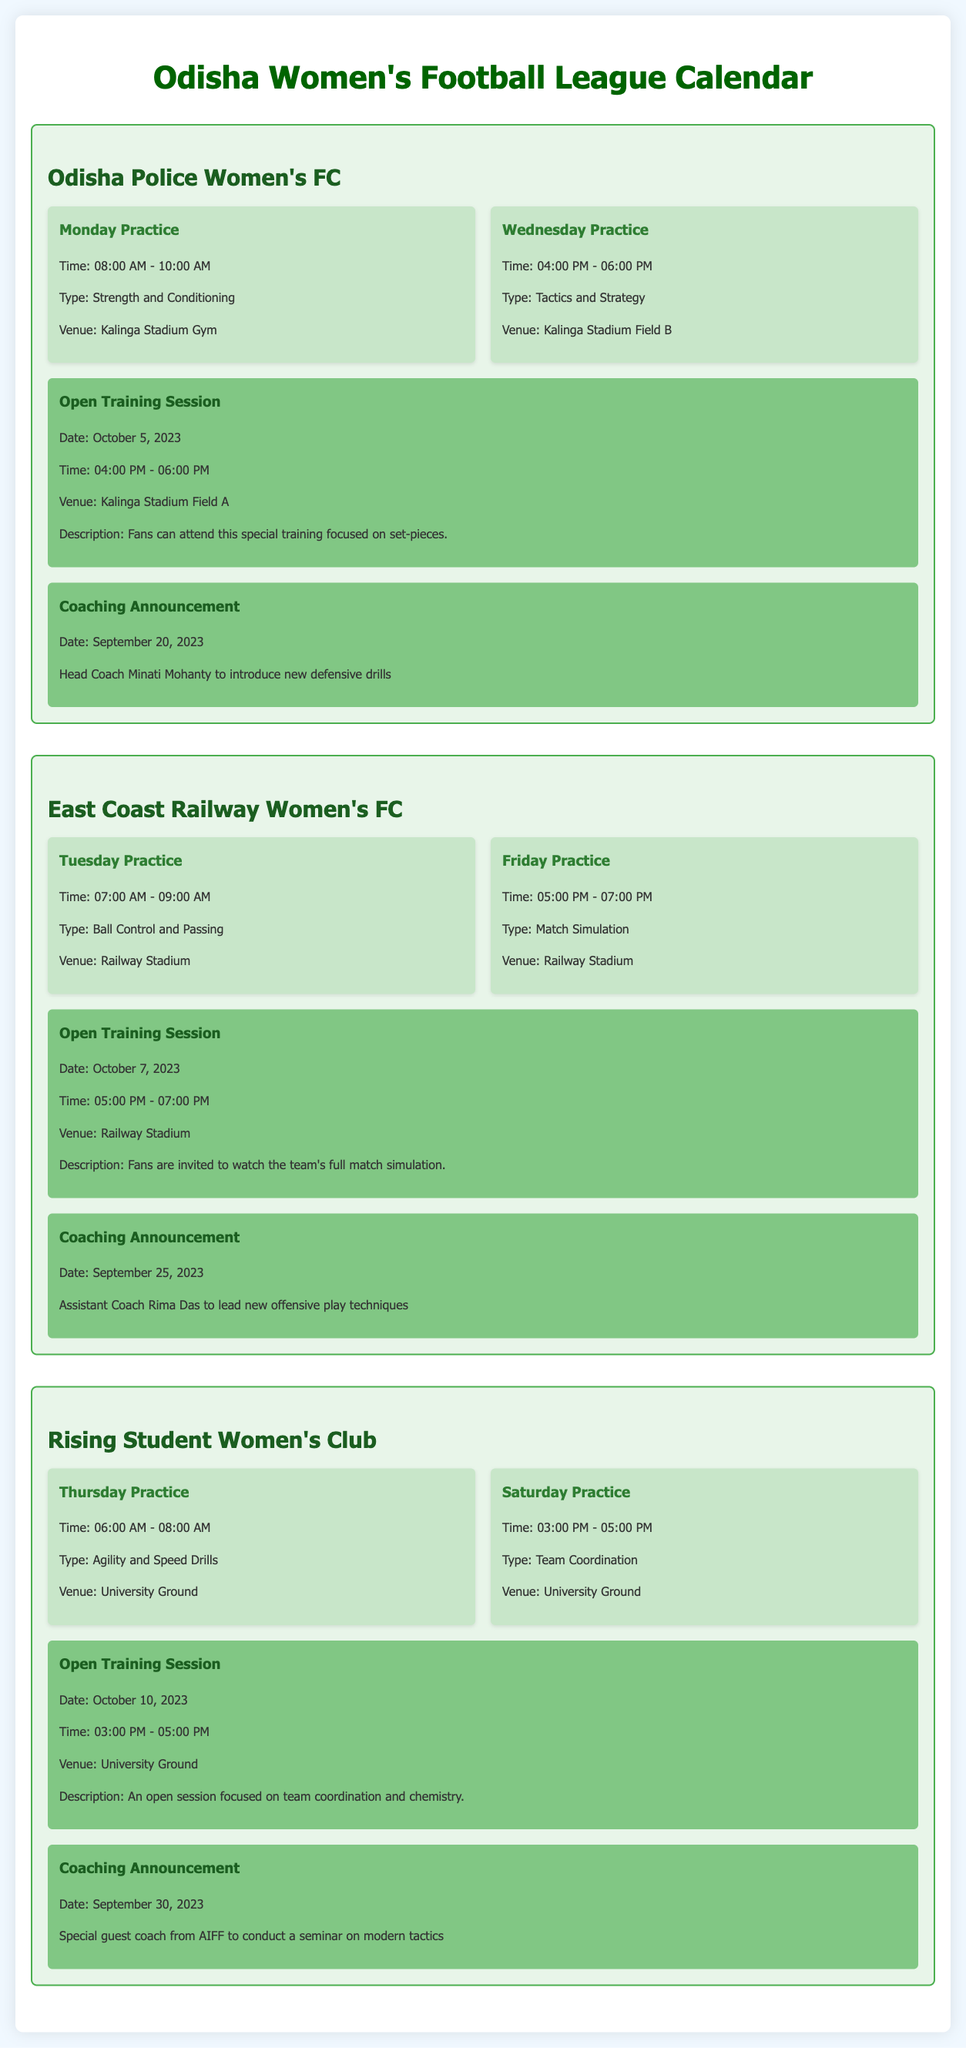what is the venue for the open training session on October 5, 2023? The venue for the open training session on October 5, 2023, is Kalinga Stadium Field A.
Answer: Kalinga Stadium Field A who is the head coach of Odisha Police Women's FC? The head coach of Odisha Police Women's FC is Minati Mohanty.
Answer: Minati Mohanty on which day does East Coast Railway Women's FC have practice focused on Ball Control and Passing? East Coast Railway Women's FC has practice focused on Ball Control and Passing on Tuesday.
Answer: Tuesday what type of practice is scheduled for Rising Student Women's Club on Thursday? The type of practice scheduled for Rising Student Women's Club on Thursday is Agility and Speed Drills.
Answer: Agility and Speed Drills how long is the open training session on October 10, 2023? The open training session on October 10, 2023, is from 03:00 PM to 05:00 PM, which is 2 hours long.
Answer: 2 hours what coaching announcement was made on September 30, 2023? The coaching announcement made on September 30, 2023, is that a special guest coach from AIFF will conduct a seminar on modern tactics.
Answer: special guest coach from AIFF to conduct a seminar on modern tactics what is the time for Friday practice for East Coast Railway Women's FC? The time for Friday practice for East Coast Railway Women's FC is 05:00 PM to 07:00 PM.
Answer: 05:00 PM - 07:00 PM who will lead the new offensive play techniques for East Coast Railway Women's FC? The assistant coach Rima Das will lead the new offensive play techniques for East Coast Railway Women's FC.
Answer: Rima Das 